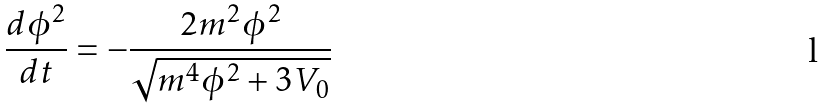<formula> <loc_0><loc_0><loc_500><loc_500>\frac { d \phi ^ { 2 } } { d t } = - \frac { 2 m ^ { 2 } \phi ^ { 2 } } { \sqrt { m ^ { 4 } \phi ^ { 2 } + 3 V _ { 0 } } }</formula> 